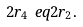<formula> <loc_0><loc_0><loc_500><loc_500>2 r _ { 4 } \ e q 2 r _ { 2 } .</formula> 